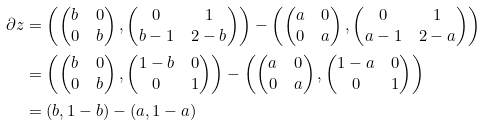<formula> <loc_0><loc_0><loc_500><loc_500>\partial z & = \left ( \begin{pmatrix} b & 0 \\ 0 & b \end{pmatrix} , \begin{pmatrix} 0 & 1 \\ b - 1 & 2 - b \end{pmatrix} \right ) - \left ( \begin{pmatrix} a & 0 \\ 0 & a \end{pmatrix} , \begin{pmatrix} 0 & 1 \\ a - 1 & 2 - a \end{pmatrix} \right ) \\ & = \left ( \begin{pmatrix} b & 0 \\ 0 & b \end{pmatrix} , \begin{pmatrix} 1 - b & 0 \\ 0 & 1 \end{pmatrix} \right ) - \left ( \begin{pmatrix} a & 0 \\ 0 & a \end{pmatrix} , \begin{pmatrix} 1 - a & 0 \\ 0 & 1 \end{pmatrix} \right ) \\ & = ( b , 1 - b ) - ( a , 1 - a ) \\</formula> 